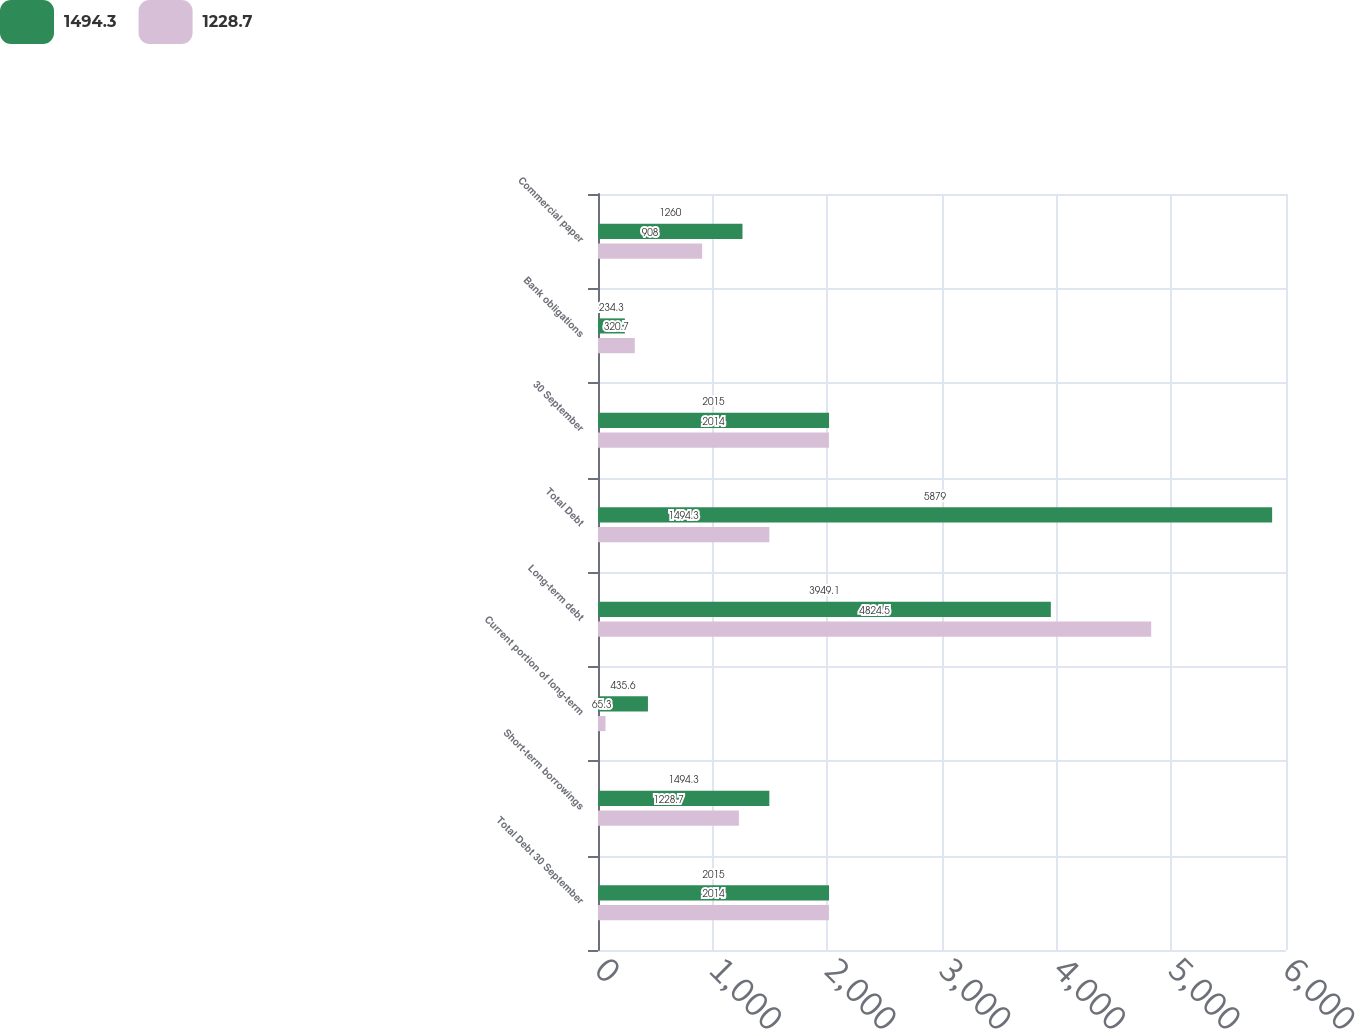Convert chart. <chart><loc_0><loc_0><loc_500><loc_500><stacked_bar_chart><ecel><fcel>Total Debt 30 September<fcel>Short-term borrowings<fcel>Current portion of long-term<fcel>Long-term debt<fcel>Total Debt<fcel>30 September<fcel>Bank obligations<fcel>Commercial paper<nl><fcel>1494.3<fcel>2015<fcel>1494.3<fcel>435.6<fcel>3949.1<fcel>5879<fcel>2015<fcel>234.3<fcel>1260<nl><fcel>1228.7<fcel>2014<fcel>1228.7<fcel>65.3<fcel>4824.5<fcel>1494.3<fcel>2014<fcel>320.7<fcel>908<nl></chart> 